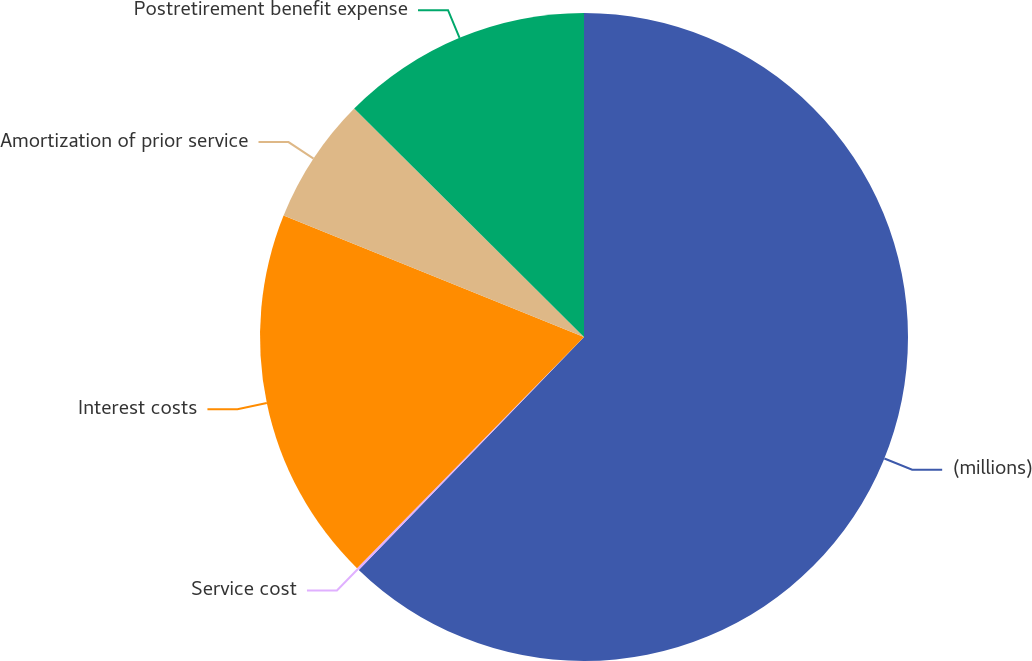Convert chart to OTSL. <chart><loc_0><loc_0><loc_500><loc_500><pie_chart><fcel>(millions)<fcel>Service cost<fcel>Interest costs<fcel>Amortization of prior service<fcel>Postretirement benefit expense<nl><fcel>62.24%<fcel>0.12%<fcel>18.76%<fcel>6.34%<fcel>12.55%<nl></chart> 